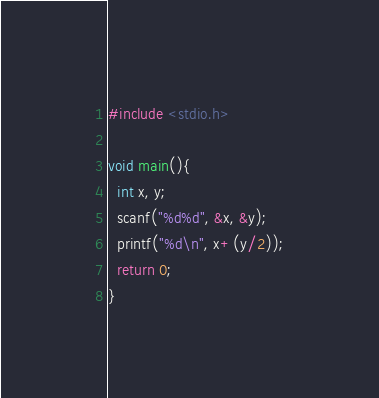Convert code to text. <code><loc_0><loc_0><loc_500><loc_500><_C_>#include <stdio.h>

void main(){
  int x, y;
  scanf("%d%d", &x, &y);
  printf("%d\n", x+(y/2));
  return 0;
}</code> 